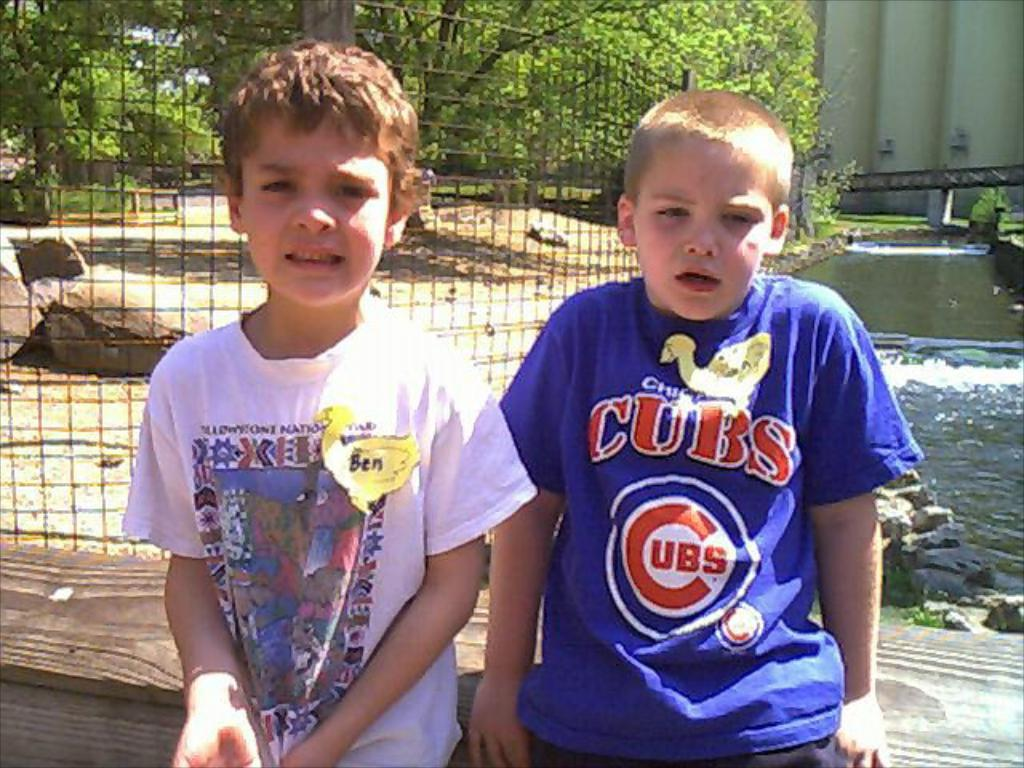<image>
Create a compact narrative representing the image presented. A little boy in a blue Chicago Cubs tshirt sits next to a boy named Ben 